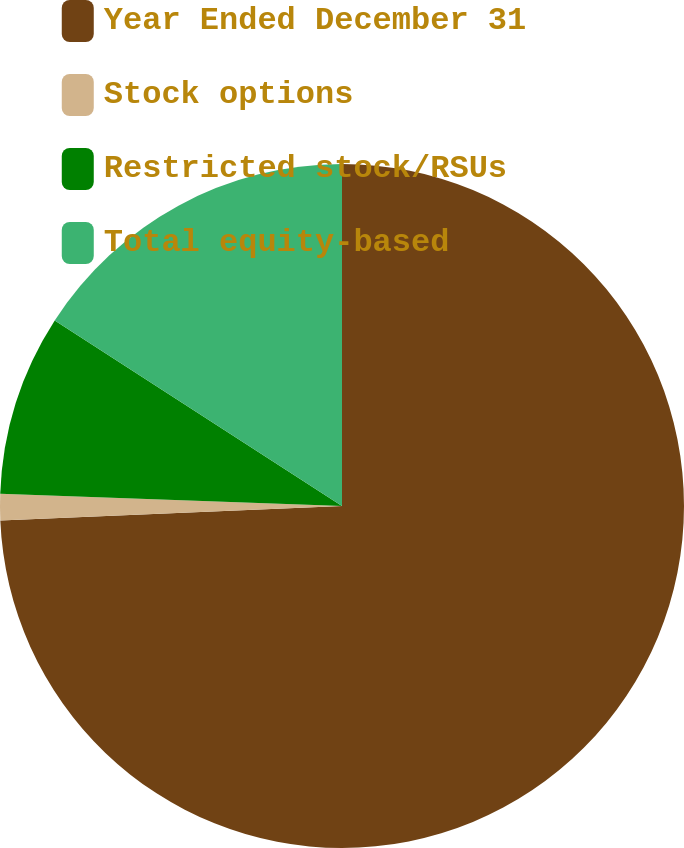Convert chart to OTSL. <chart><loc_0><loc_0><loc_500><loc_500><pie_chart><fcel>Year Ended December 31<fcel>Stock options<fcel>Restricted stock/RSUs<fcel>Total equity-based<nl><fcel>74.32%<fcel>1.25%<fcel>8.56%<fcel>15.87%<nl></chart> 